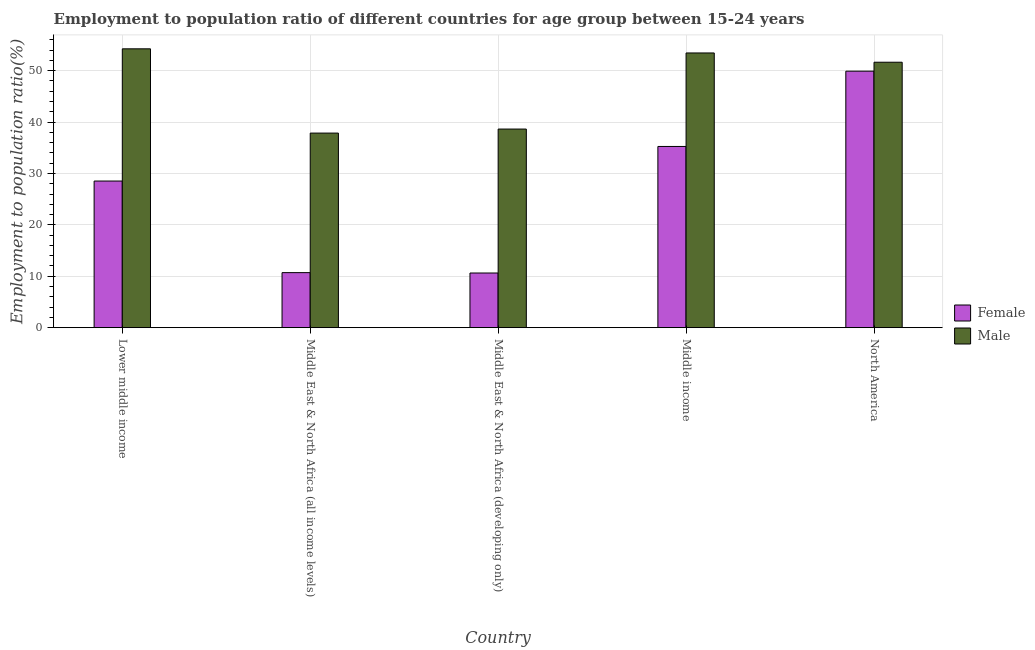How many groups of bars are there?
Offer a terse response. 5. How many bars are there on the 4th tick from the right?
Give a very brief answer. 2. What is the label of the 2nd group of bars from the left?
Provide a short and direct response. Middle East & North Africa (all income levels). In how many cases, is the number of bars for a given country not equal to the number of legend labels?
Provide a short and direct response. 0. What is the employment to population ratio(female) in Middle East & North Africa (all income levels)?
Ensure brevity in your answer.  10.71. Across all countries, what is the maximum employment to population ratio(male)?
Make the answer very short. 54.24. Across all countries, what is the minimum employment to population ratio(male)?
Your answer should be compact. 37.85. In which country was the employment to population ratio(male) maximum?
Your answer should be compact. Lower middle income. In which country was the employment to population ratio(female) minimum?
Ensure brevity in your answer.  Middle East & North Africa (developing only). What is the total employment to population ratio(male) in the graph?
Your answer should be compact. 235.8. What is the difference between the employment to population ratio(female) in Middle East & North Africa (developing only) and that in Middle income?
Give a very brief answer. -24.62. What is the difference between the employment to population ratio(female) in Lower middle income and the employment to population ratio(male) in Middle East & North Africa (developing only)?
Give a very brief answer. -10.11. What is the average employment to population ratio(female) per country?
Offer a very short reply. 27. What is the difference between the employment to population ratio(female) and employment to population ratio(male) in Middle income?
Offer a terse response. -18.19. What is the ratio of the employment to population ratio(male) in Middle East & North Africa (developing only) to that in Middle income?
Give a very brief answer. 0.72. Is the employment to population ratio(female) in Middle East & North Africa (all income levels) less than that in Middle income?
Offer a very short reply. Yes. What is the difference between the highest and the second highest employment to population ratio(female)?
Provide a succinct answer. 14.65. What is the difference between the highest and the lowest employment to population ratio(female)?
Offer a very short reply. 39.26. In how many countries, is the employment to population ratio(male) greater than the average employment to population ratio(male) taken over all countries?
Give a very brief answer. 3. How many bars are there?
Your response must be concise. 10. How many countries are there in the graph?
Offer a terse response. 5. What is the difference between two consecutive major ticks on the Y-axis?
Your response must be concise. 10. Does the graph contain any zero values?
Offer a very short reply. No. Does the graph contain grids?
Make the answer very short. Yes. What is the title of the graph?
Your answer should be very brief. Employment to population ratio of different countries for age group between 15-24 years. What is the label or title of the Y-axis?
Your answer should be very brief. Employment to population ratio(%). What is the Employment to population ratio(%) in Female in Lower middle income?
Make the answer very short. 28.52. What is the Employment to population ratio(%) in Male in Lower middle income?
Offer a terse response. 54.24. What is the Employment to population ratio(%) in Female in Middle East & North Africa (all income levels)?
Offer a terse response. 10.71. What is the Employment to population ratio(%) in Male in Middle East & North Africa (all income levels)?
Offer a very short reply. 37.85. What is the Employment to population ratio(%) in Female in Middle East & North Africa (developing only)?
Offer a terse response. 10.63. What is the Employment to population ratio(%) of Male in Middle East & North Africa (developing only)?
Offer a terse response. 38.63. What is the Employment to population ratio(%) of Female in Middle income?
Offer a very short reply. 35.25. What is the Employment to population ratio(%) of Male in Middle income?
Offer a terse response. 53.44. What is the Employment to population ratio(%) of Female in North America?
Give a very brief answer. 49.9. What is the Employment to population ratio(%) of Male in North America?
Make the answer very short. 51.63. Across all countries, what is the maximum Employment to population ratio(%) of Female?
Your answer should be compact. 49.9. Across all countries, what is the maximum Employment to population ratio(%) of Male?
Your response must be concise. 54.24. Across all countries, what is the minimum Employment to population ratio(%) of Female?
Provide a succinct answer. 10.63. Across all countries, what is the minimum Employment to population ratio(%) of Male?
Offer a very short reply. 37.85. What is the total Employment to population ratio(%) of Female in the graph?
Offer a very short reply. 135. What is the total Employment to population ratio(%) of Male in the graph?
Offer a terse response. 235.8. What is the difference between the Employment to population ratio(%) in Female in Lower middle income and that in Middle East & North Africa (all income levels)?
Your response must be concise. 17.82. What is the difference between the Employment to population ratio(%) in Male in Lower middle income and that in Middle East & North Africa (all income levels)?
Give a very brief answer. 16.39. What is the difference between the Employment to population ratio(%) of Female in Lower middle income and that in Middle East & North Africa (developing only)?
Provide a succinct answer. 17.89. What is the difference between the Employment to population ratio(%) of Male in Lower middle income and that in Middle East & North Africa (developing only)?
Provide a succinct answer. 15.61. What is the difference between the Employment to population ratio(%) in Female in Lower middle income and that in Middle income?
Your answer should be very brief. -6.73. What is the difference between the Employment to population ratio(%) of Male in Lower middle income and that in Middle income?
Keep it short and to the point. 0.81. What is the difference between the Employment to population ratio(%) of Female in Lower middle income and that in North America?
Your answer should be very brief. -21.37. What is the difference between the Employment to population ratio(%) in Male in Lower middle income and that in North America?
Your answer should be very brief. 2.61. What is the difference between the Employment to population ratio(%) in Female in Middle East & North Africa (all income levels) and that in Middle East & North Africa (developing only)?
Keep it short and to the point. 0.07. What is the difference between the Employment to population ratio(%) in Male in Middle East & North Africa (all income levels) and that in Middle East & North Africa (developing only)?
Keep it short and to the point. -0.79. What is the difference between the Employment to population ratio(%) of Female in Middle East & North Africa (all income levels) and that in Middle income?
Offer a very short reply. -24.54. What is the difference between the Employment to population ratio(%) in Male in Middle East & North Africa (all income levels) and that in Middle income?
Offer a very short reply. -15.59. What is the difference between the Employment to population ratio(%) of Female in Middle East & North Africa (all income levels) and that in North America?
Provide a short and direct response. -39.19. What is the difference between the Employment to population ratio(%) in Male in Middle East & North Africa (all income levels) and that in North America?
Your answer should be compact. -13.78. What is the difference between the Employment to population ratio(%) in Female in Middle East & North Africa (developing only) and that in Middle income?
Your answer should be very brief. -24.62. What is the difference between the Employment to population ratio(%) of Male in Middle East & North Africa (developing only) and that in Middle income?
Your answer should be very brief. -14.8. What is the difference between the Employment to population ratio(%) in Female in Middle East & North Africa (developing only) and that in North America?
Your response must be concise. -39.26. What is the difference between the Employment to population ratio(%) of Male in Middle East & North Africa (developing only) and that in North America?
Your answer should be very brief. -13. What is the difference between the Employment to population ratio(%) of Female in Middle income and that in North America?
Offer a terse response. -14.65. What is the difference between the Employment to population ratio(%) of Male in Middle income and that in North America?
Your answer should be compact. 1.8. What is the difference between the Employment to population ratio(%) of Female in Lower middle income and the Employment to population ratio(%) of Male in Middle East & North Africa (all income levels)?
Your response must be concise. -9.33. What is the difference between the Employment to population ratio(%) in Female in Lower middle income and the Employment to population ratio(%) in Male in Middle East & North Africa (developing only)?
Your answer should be very brief. -10.11. What is the difference between the Employment to population ratio(%) in Female in Lower middle income and the Employment to population ratio(%) in Male in Middle income?
Ensure brevity in your answer.  -24.91. What is the difference between the Employment to population ratio(%) in Female in Lower middle income and the Employment to population ratio(%) in Male in North America?
Your answer should be very brief. -23.11. What is the difference between the Employment to population ratio(%) of Female in Middle East & North Africa (all income levels) and the Employment to population ratio(%) of Male in Middle East & North Africa (developing only)?
Provide a short and direct response. -27.93. What is the difference between the Employment to population ratio(%) in Female in Middle East & North Africa (all income levels) and the Employment to population ratio(%) in Male in Middle income?
Provide a succinct answer. -42.73. What is the difference between the Employment to population ratio(%) of Female in Middle East & North Africa (all income levels) and the Employment to population ratio(%) of Male in North America?
Your response must be concise. -40.93. What is the difference between the Employment to population ratio(%) of Female in Middle East & North Africa (developing only) and the Employment to population ratio(%) of Male in Middle income?
Keep it short and to the point. -42.8. What is the difference between the Employment to population ratio(%) of Female in Middle East & North Africa (developing only) and the Employment to population ratio(%) of Male in North America?
Your response must be concise. -41. What is the difference between the Employment to population ratio(%) in Female in Middle income and the Employment to population ratio(%) in Male in North America?
Make the answer very short. -16.38. What is the average Employment to population ratio(%) in Female per country?
Offer a very short reply. 27. What is the average Employment to population ratio(%) in Male per country?
Provide a succinct answer. 47.16. What is the difference between the Employment to population ratio(%) in Female and Employment to population ratio(%) in Male in Lower middle income?
Offer a very short reply. -25.72. What is the difference between the Employment to population ratio(%) in Female and Employment to population ratio(%) in Male in Middle East & North Africa (all income levels)?
Make the answer very short. -27.14. What is the difference between the Employment to population ratio(%) of Female and Employment to population ratio(%) of Male in Middle East & North Africa (developing only)?
Offer a very short reply. -28. What is the difference between the Employment to population ratio(%) of Female and Employment to population ratio(%) of Male in Middle income?
Make the answer very short. -18.19. What is the difference between the Employment to population ratio(%) in Female and Employment to population ratio(%) in Male in North America?
Your answer should be very brief. -1.74. What is the ratio of the Employment to population ratio(%) in Female in Lower middle income to that in Middle East & North Africa (all income levels)?
Your response must be concise. 2.66. What is the ratio of the Employment to population ratio(%) of Male in Lower middle income to that in Middle East & North Africa (all income levels)?
Provide a succinct answer. 1.43. What is the ratio of the Employment to population ratio(%) in Female in Lower middle income to that in Middle East & North Africa (developing only)?
Give a very brief answer. 2.68. What is the ratio of the Employment to population ratio(%) in Male in Lower middle income to that in Middle East & North Africa (developing only)?
Your answer should be compact. 1.4. What is the ratio of the Employment to population ratio(%) of Female in Lower middle income to that in Middle income?
Your answer should be very brief. 0.81. What is the ratio of the Employment to population ratio(%) of Male in Lower middle income to that in Middle income?
Your answer should be very brief. 1.02. What is the ratio of the Employment to population ratio(%) of Female in Lower middle income to that in North America?
Your response must be concise. 0.57. What is the ratio of the Employment to population ratio(%) in Male in Lower middle income to that in North America?
Ensure brevity in your answer.  1.05. What is the ratio of the Employment to population ratio(%) of Female in Middle East & North Africa (all income levels) to that in Middle East & North Africa (developing only)?
Offer a very short reply. 1.01. What is the ratio of the Employment to population ratio(%) in Male in Middle East & North Africa (all income levels) to that in Middle East & North Africa (developing only)?
Your answer should be compact. 0.98. What is the ratio of the Employment to population ratio(%) in Female in Middle East & North Africa (all income levels) to that in Middle income?
Keep it short and to the point. 0.3. What is the ratio of the Employment to population ratio(%) of Male in Middle East & North Africa (all income levels) to that in Middle income?
Offer a very short reply. 0.71. What is the ratio of the Employment to population ratio(%) of Female in Middle East & North Africa (all income levels) to that in North America?
Ensure brevity in your answer.  0.21. What is the ratio of the Employment to population ratio(%) of Male in Middle East & North Africa (all income levels) to that in North America?
Provide a short and direct response. 0.73. What is the ratio of the Employment to population ratio(%) in Female in Middle East & North Africa (developing only) to that in Middle income?
Provide a short and direct response. 0.3. What is the ratio of the Employment to population ratio(%) in Male in Middle East & North Africa (developing only) to that in Middle income?
Make the answer very short. 0.72. What is the ratio of the Employment to population ratio(%) in Female in Middle East & North Africa (developing only) to that in North America?
Provide a succinct answer. 0.21. What is the ratio of the Employment to population ratio(%) in Male in Middle East & North Africa (developing only) to that in North America?
Provide a short and direct response. 0.75. What is the ratio of the Employment to population ratio(%) in Female in Middle income to that in North America?
Offer a very short reply. 0.71. What is the ratio of the Employment to population ratio(%) in Male in Middle income to that in North America?
Provide a succinct answer. 1.03. What is the difference between the highest and the second highest Employment to population ratio(%) in Female?
Your answer should be very brief. 14.65. What is the difference between the highest and the second highest Employment to population ratio(%) in Male?
Provide a succinct answer. 0.81. What is the difference between the highest and the lowest Employment to population ratio(%) of Female?
Make the answer very short. 39.26. What is the difference between the highest and the lowest Employment to population ratio(%) of Male?
Offer a terse response. 16.39. 